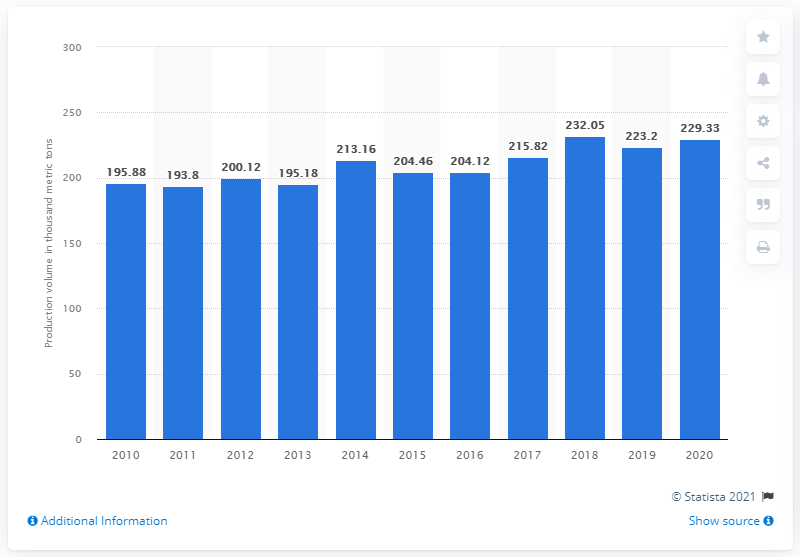Point out several critical features in this image. In 2020, the production volume of plastic bags in Taiwan was 229,330 units. 